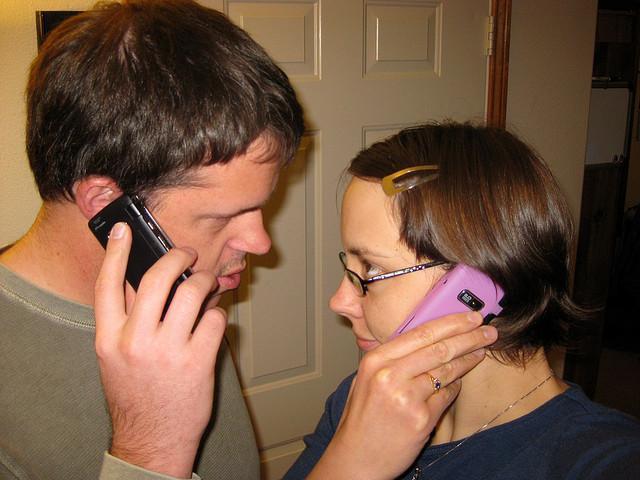How many people are in the photo?
Give a very brief answer. 2. How many cell phones can be seen?
Give a very brief answer. 2. 